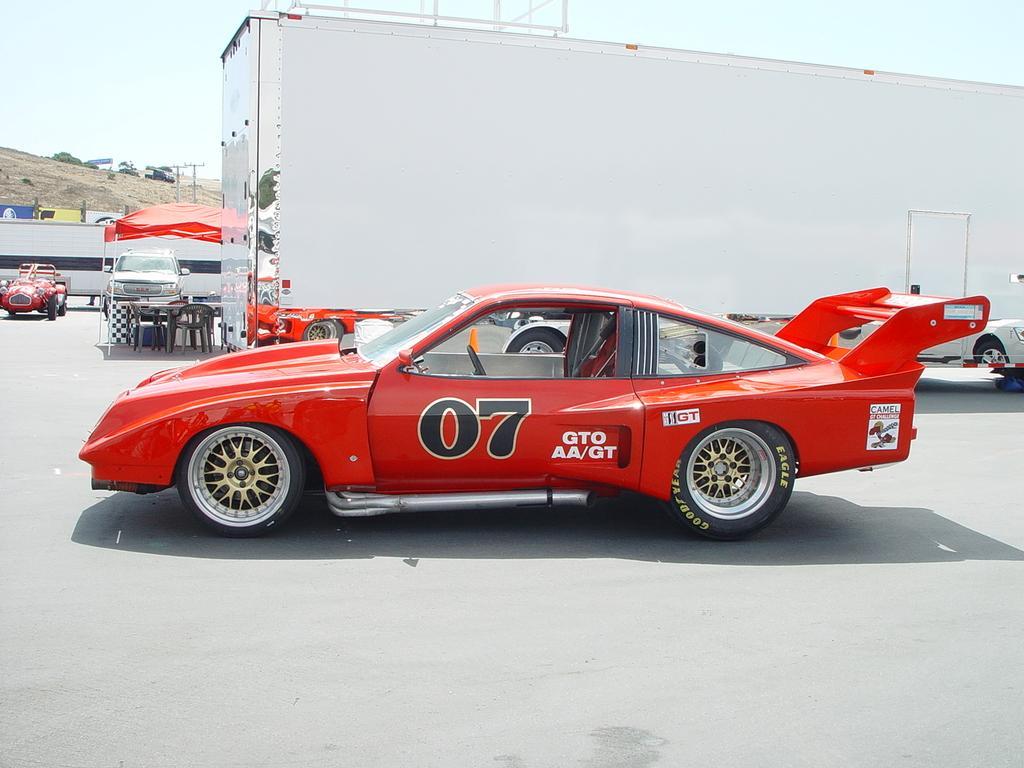In one or two sentences, can you explain what this image depicts? In this image there are cars on the path , container , tent with poles, chairs, table, and in the background there are trees, sky. 